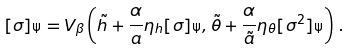<formula> <loc_0><loc_0><loc_500><loc_500>[ \sigma ] _ { \Psi } = V _ { \beta } \left ( \tilde { h } + \frac { \alpha } { a } \eta _ { h } [ \sigma ] _ { \Psi } , \tilde { \theta } + \frac { \alpha } { \tilde { a } } \eta _ { \theta } [ \sigma ^ { 2 } ] _ { \Psi } \right ) \, .</formula> 